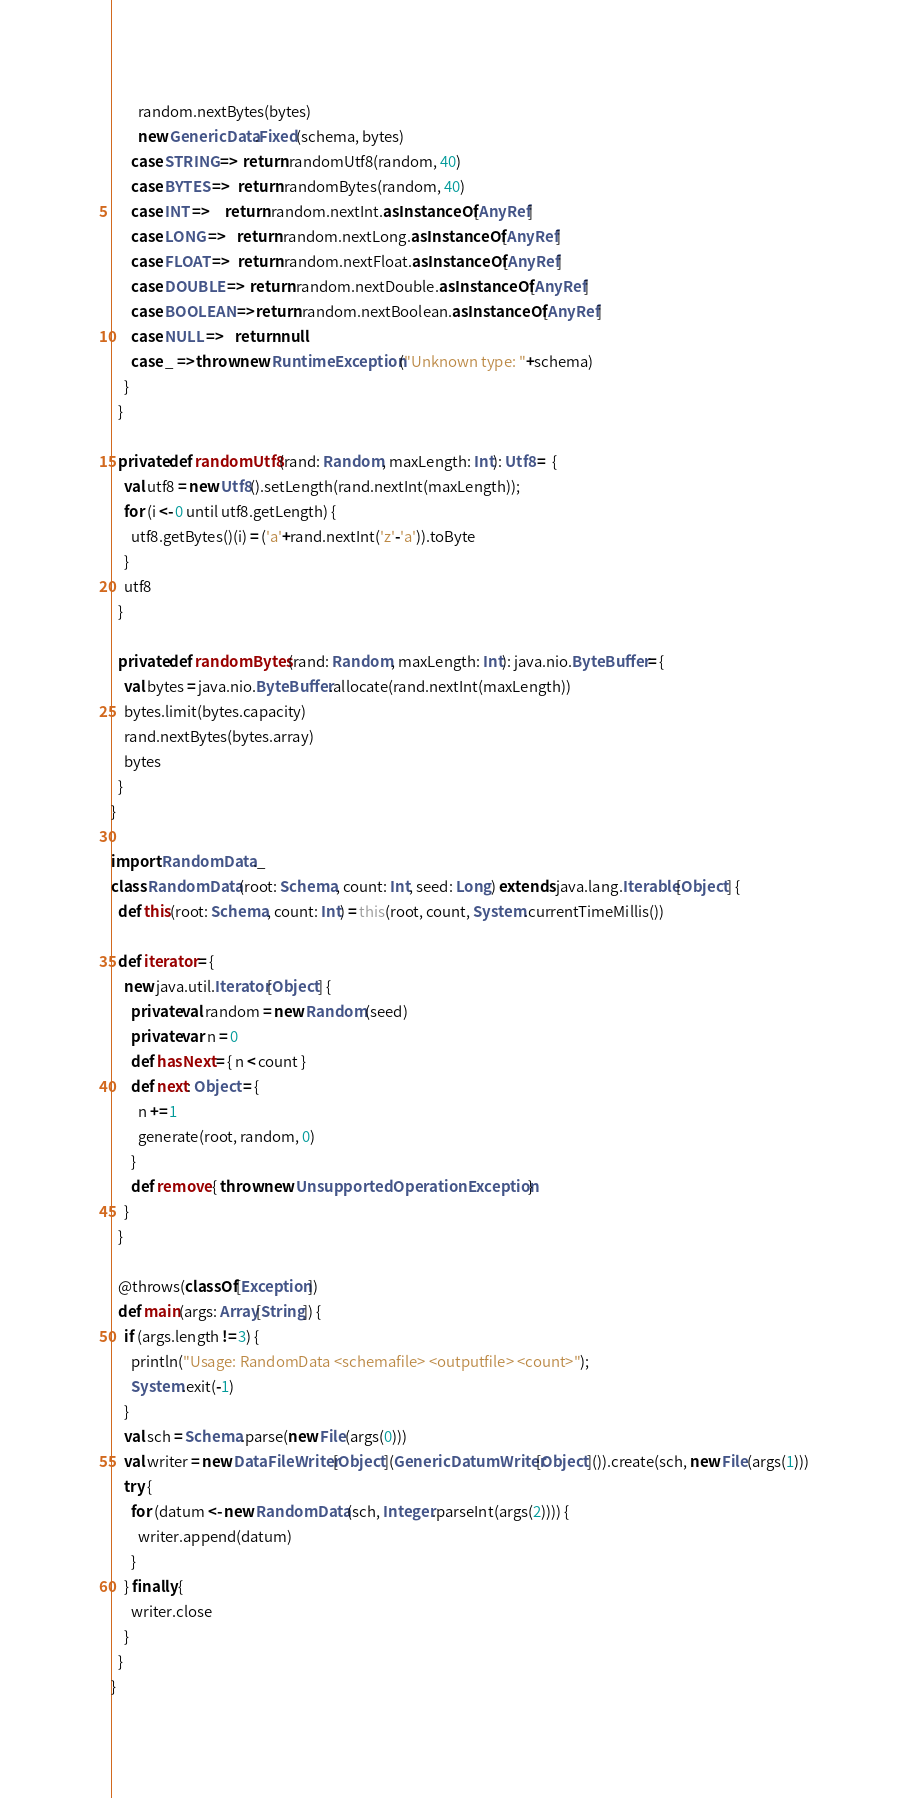Convert code to text. <code><loc_0><loc_0><loc_500><loc_500><_Scala_>        random.nextBytes(bytes)
        new GenericData.Fixed(schema, bytes)
      case STRING =>  return randomUtf8(random, 40)
      case BYTES =>   return randomBytes(random, 40)
      case INT =>     return random.nextInt.asInstanceOf[AnyRef]
      case LONG =>    return random.nextLong.asInstanceOf[AnyRef]
      case FLOAT =>   return random.nextFloat.asInstanceOf[AnyRef]
      case DOUBLE =>  return random.nextDouble.asInstanceOf[AnyRef]
      case BOOLEAN => return random.nextBoolean.asInstanceOf[AnyRef]
      case NULL =>    return null
      case _ => throw new RuntimeException("Unknown type: "+schema)
    }
  }

  private def randomUtf8(rand: Random, maxLength: Int): Utf8 =  {
    val utf8 = new Utf8().setLength(rand.nextInt(maxLength));
    for (i <- 0 until utf8.getLength) {
      utf8.getBytes()(i) = ('a'+rand.nextInt('z'-'a')).toByte
    }
    utf8
  }

  private def randomBytes(rand: Random, maxLength: Int): java.nio.ByteBuffer = {
    val bytes = java.nio.ByteBuffer.allocate(rand.nextInt(maxLength))
    bytes.limit(bytes.capacity)
    rand.nextBytes(bytes.array)
    bytes
  }
}

import RandomData._
class RandomData(root: Schema, count: Int, seed: Long) extends java.lang.Iterable[Object] {
  def this(root: Schema, count: Int) = this(root, count, System.currentTimeMillis())

  def iterator = {
    new java.util.Iterator[Object] {
      private val random = new Random(seed)
      private var n = 0
      def hasNext = { n < count }
      def next: Object = {
        n += 1
        generate(root, random, 0)
      }
      def remove { throw new UnsupportedOperationException }
    }
  }

  @throws(classOf[Exception])
  def main(args: Array[String]) {
    if (args.length != 3) {
      println("Usage: RandomData <schemafile> <outputfile> <count>");
      System.exit(-1)
    }
    val sch = Schema.parse(new File(args(0)))
    val writer = new DataFileWriter[Object](GenericDatumWriter[Object]()).create(sch, new File(args(1)))
    try {
      for (datum <- new RandomData(sch, Integer.parseInt(args(2)))) {
        writer.append(datum)
      }
    } finally {
      writer.close
    }
  }
}
</code> 